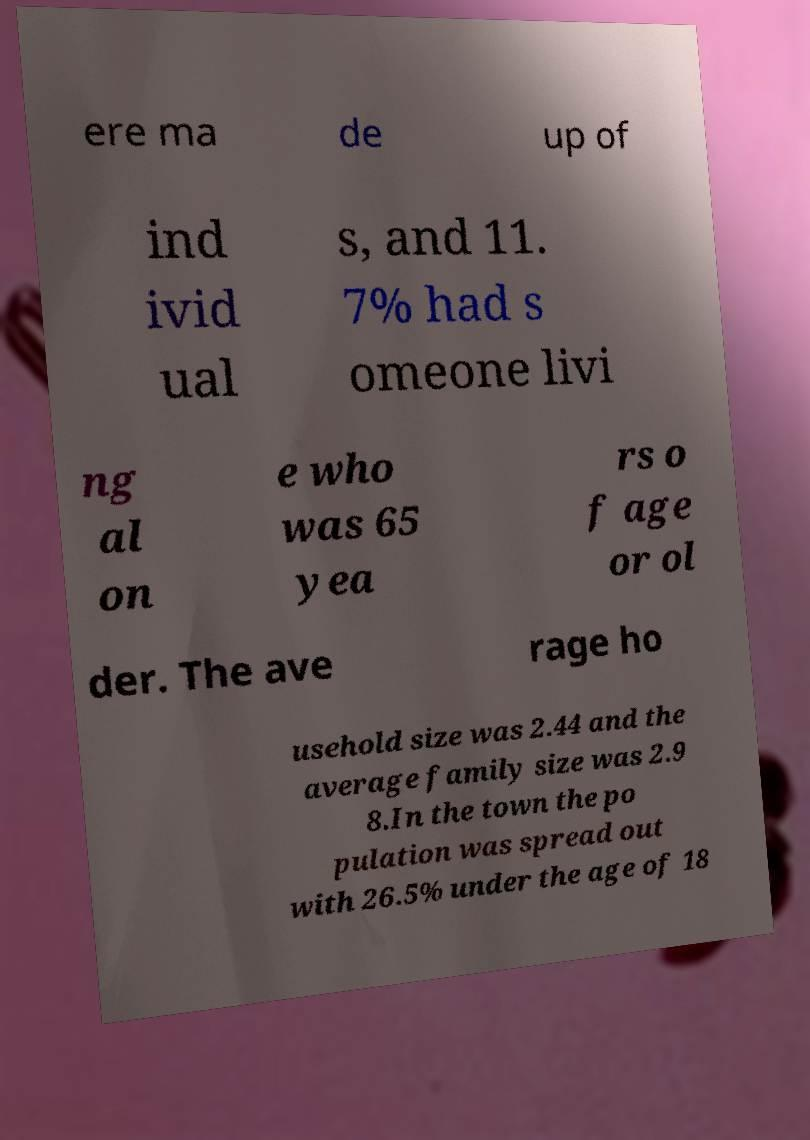For documentation purposes, I need the text within this image transcribed. Could you provide that? ere ma de up of ind ivid ual s, and 11. 7% had s omeone livi ng al on e who was 65 yea rs o f age or ol der. The ave rage ho usehold size was 2.44 and the average family size was 2.9 8.In the town the po pulation was spread out with 26.5% under the age of 18 